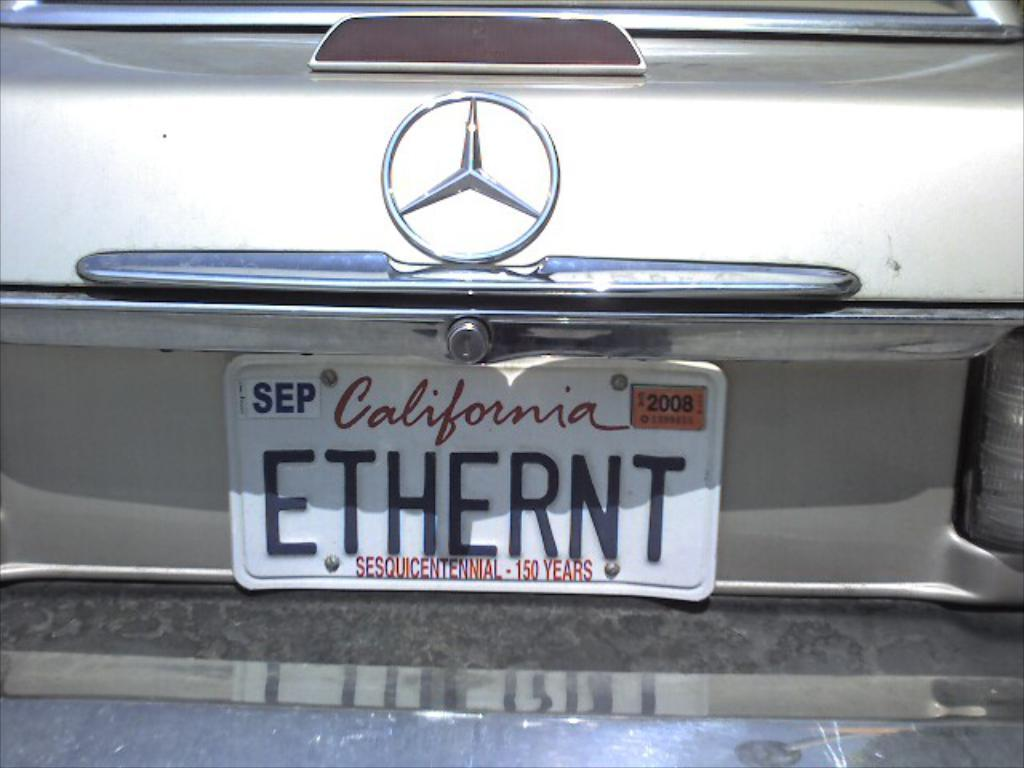Provide a one-sentence caption for the provided image. A Mercedes has a California license plate with a yellow 2008 sticker in the corner. 